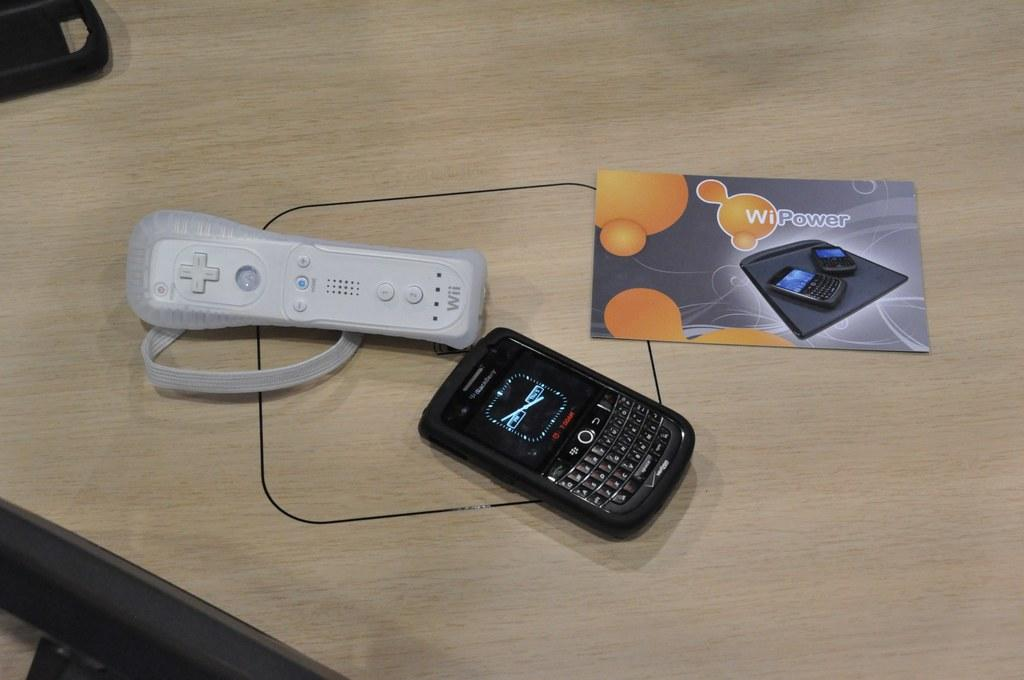<image>
Summarize the visual content of the image. A Blackberry sitting next to a Wii controller on a WiiPower charger. 